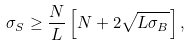<formula> <loc_0><loc_0><loc_500><loc_500>\sigma _ { S } \geq \frac { N } { L } \left [ N + 2 \sqrt { L \sigma _ { B } } \right ] ,</formula> 